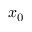<formula> <loc_0><loc_0><loc_500><loc_500>x _ { 0 }</formula> 